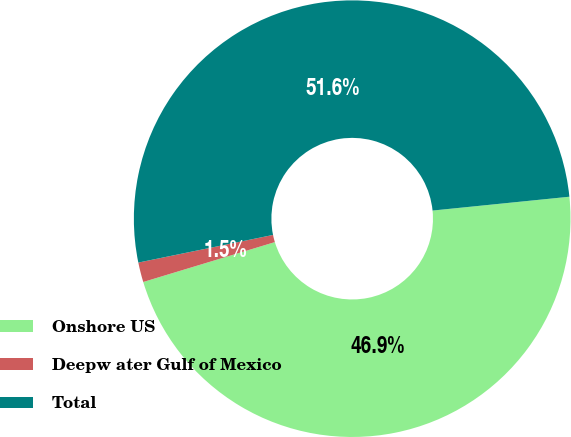<chart> <loc_0><loc_0><loc_500><loc_500><pie_chart><fcel>Onshore US<fcel>Deepw ater Gulf of Mexico<fcel>Total<nl><fcel>46.92%<fcel>1.46%<fcel>51.62%<nl></chart> 